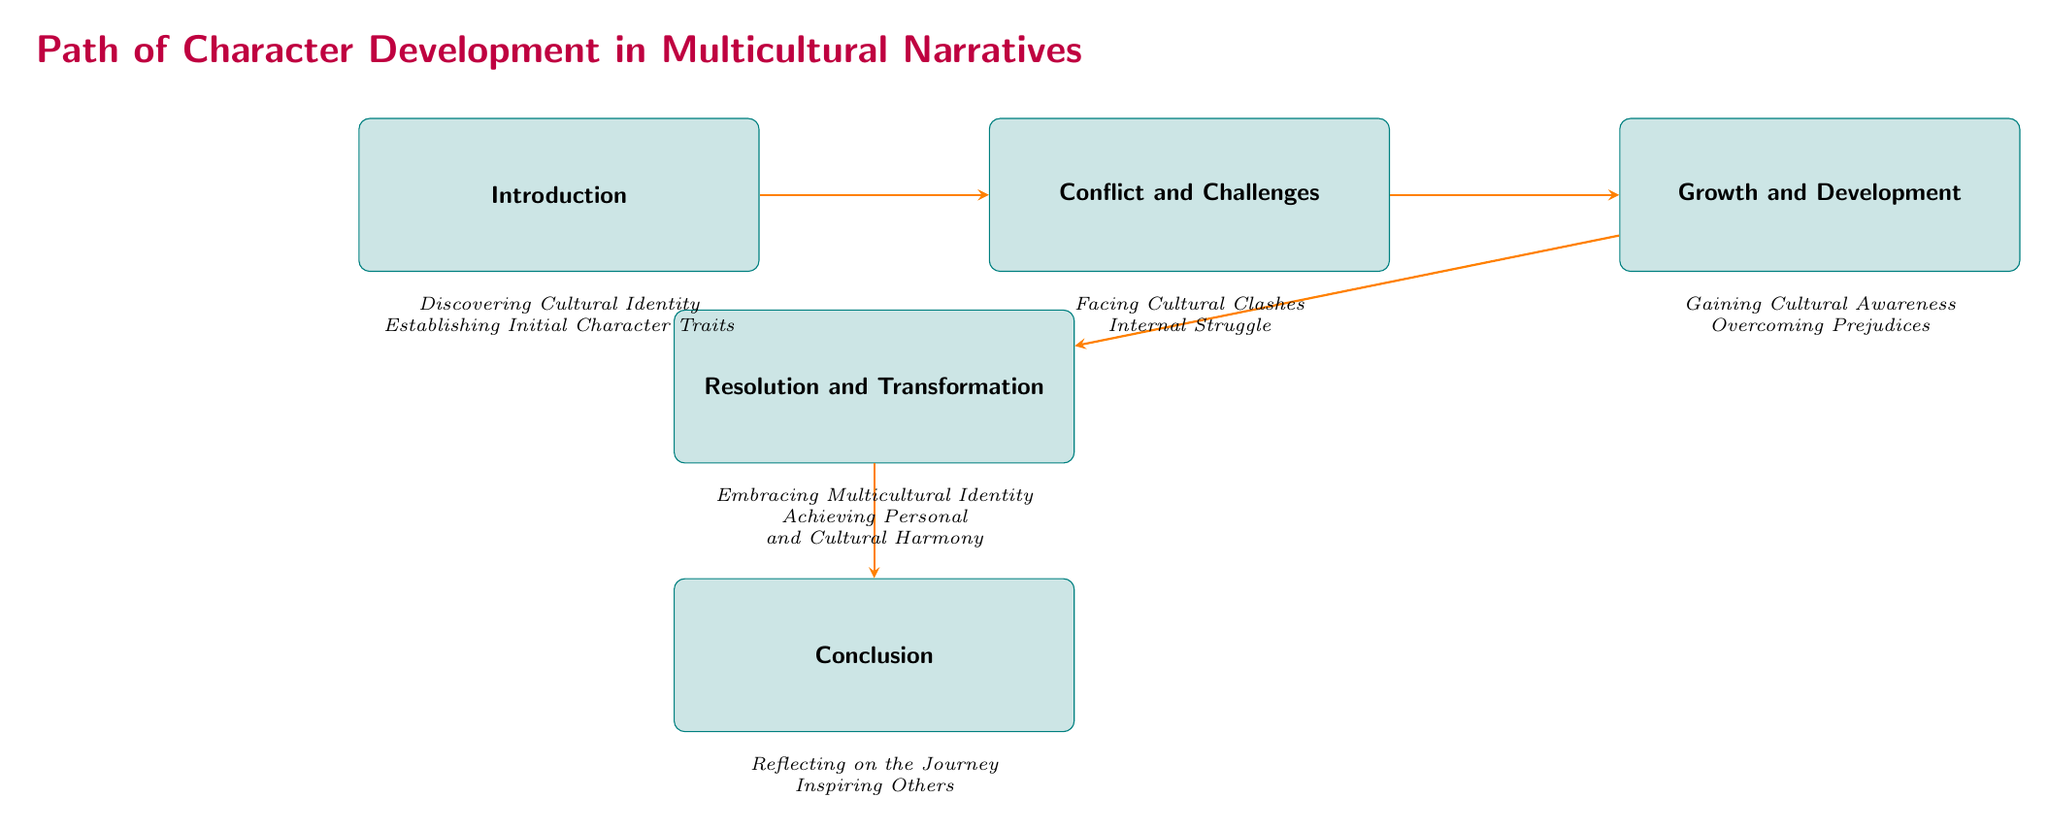What is the first step in the character development path? The first step in the path of character development is labeled 'Introduction,' which includes discovering cultural identity and establishing initial character traits.
Answer: Introduction How many main nodes are present in the flowchart? There are five main nodes in the flowchart: Introduction, Conflict and Challenges, Growth and Development, Resolution and Transformation, Conclusion.
Answer: 5 What follows the 'Conflict and Challenges' node? The flowchart indicates that 'Growth and Development' follows directly after 'Conflict and Challenges,' showing the progression in the character development path.
Answer: Growth and Development What are the two sub-nodes under 'Resolution and Transformation'? Under 'Resolution and Transformation,' there are two sub-nodes: embracing multicultural identity and achieving personal and cultural harmony, which detail the steps taken towards resolution.
Answer: Embracing Multicultural Identity, Achieving Personal and Cultural Harmony Which process is directly before 'Overcoming Prejudices'? The process directly before 'Overcoming Prejudices' is 'Gaining Cultural Awareness,' indicating the progression from understanding to challenging existing biases.
Answer: Gaining Cultural Awareness What two experiences are highlighted under 'Conflict and Challenges'? Under 'Conflict and Challenges,' the two highlighted experiences are facing cultural clashes and internal struggle, emphasizing the difficulties of navigating cultural differences.
Answer: Facing Cultural Clashes, Internal Struggle Which node emphasizes the importance of appreciating cultural diversity? The 'Conclusion' node emphasizes understanding the lessons learned from the multicultural experience and encourages readers to appreciate and respect cultural diversity.
Answer: Conclusion What is the last step in the character development path? The last step in the character development path is 'Conclusion,' which reflects on the journey and inspires others regarding cultural diversity.
Answer: Conclusion What is the key theme connected to the 'Growth and Development' node? The key theme connected to the 'Growth and Development' node is cultural transformation, mainly through gaining awareness and overcoming prejudices as part of personal development.
Answer: Cultural Transformation 